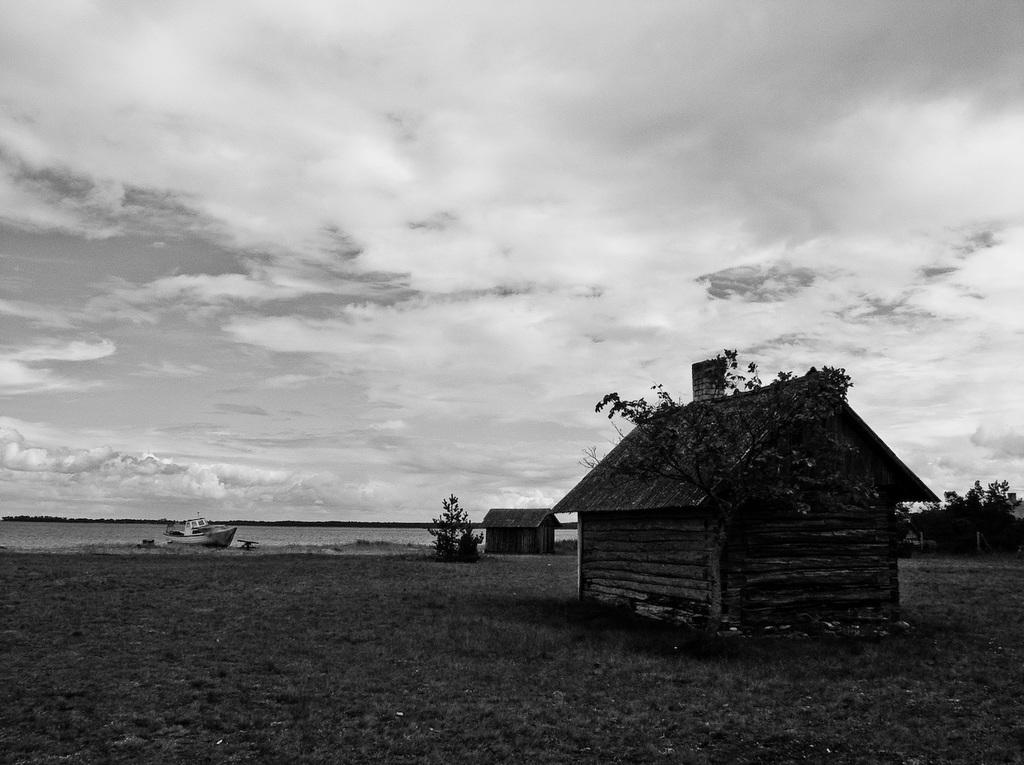What is the main subject of the picture? The main subject of the picture is a boat. What type of environment is the boat in? The boat is in an ocean. What else can be seen in the picture besides the boat? There are buildings visible in the picture. What is the condition of the sky in the picture? The sky is clear in the picture. Can you tell me how many cats are sitting on the judge's lap in the image? There is no judge or cats present in the image; it features a boat in an ocean with buildings in the background. 